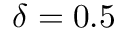Convert formula to latex. <formula><loc_0><loc_0><loc_500><loc_500>\delta = 0 . 5</formula> 